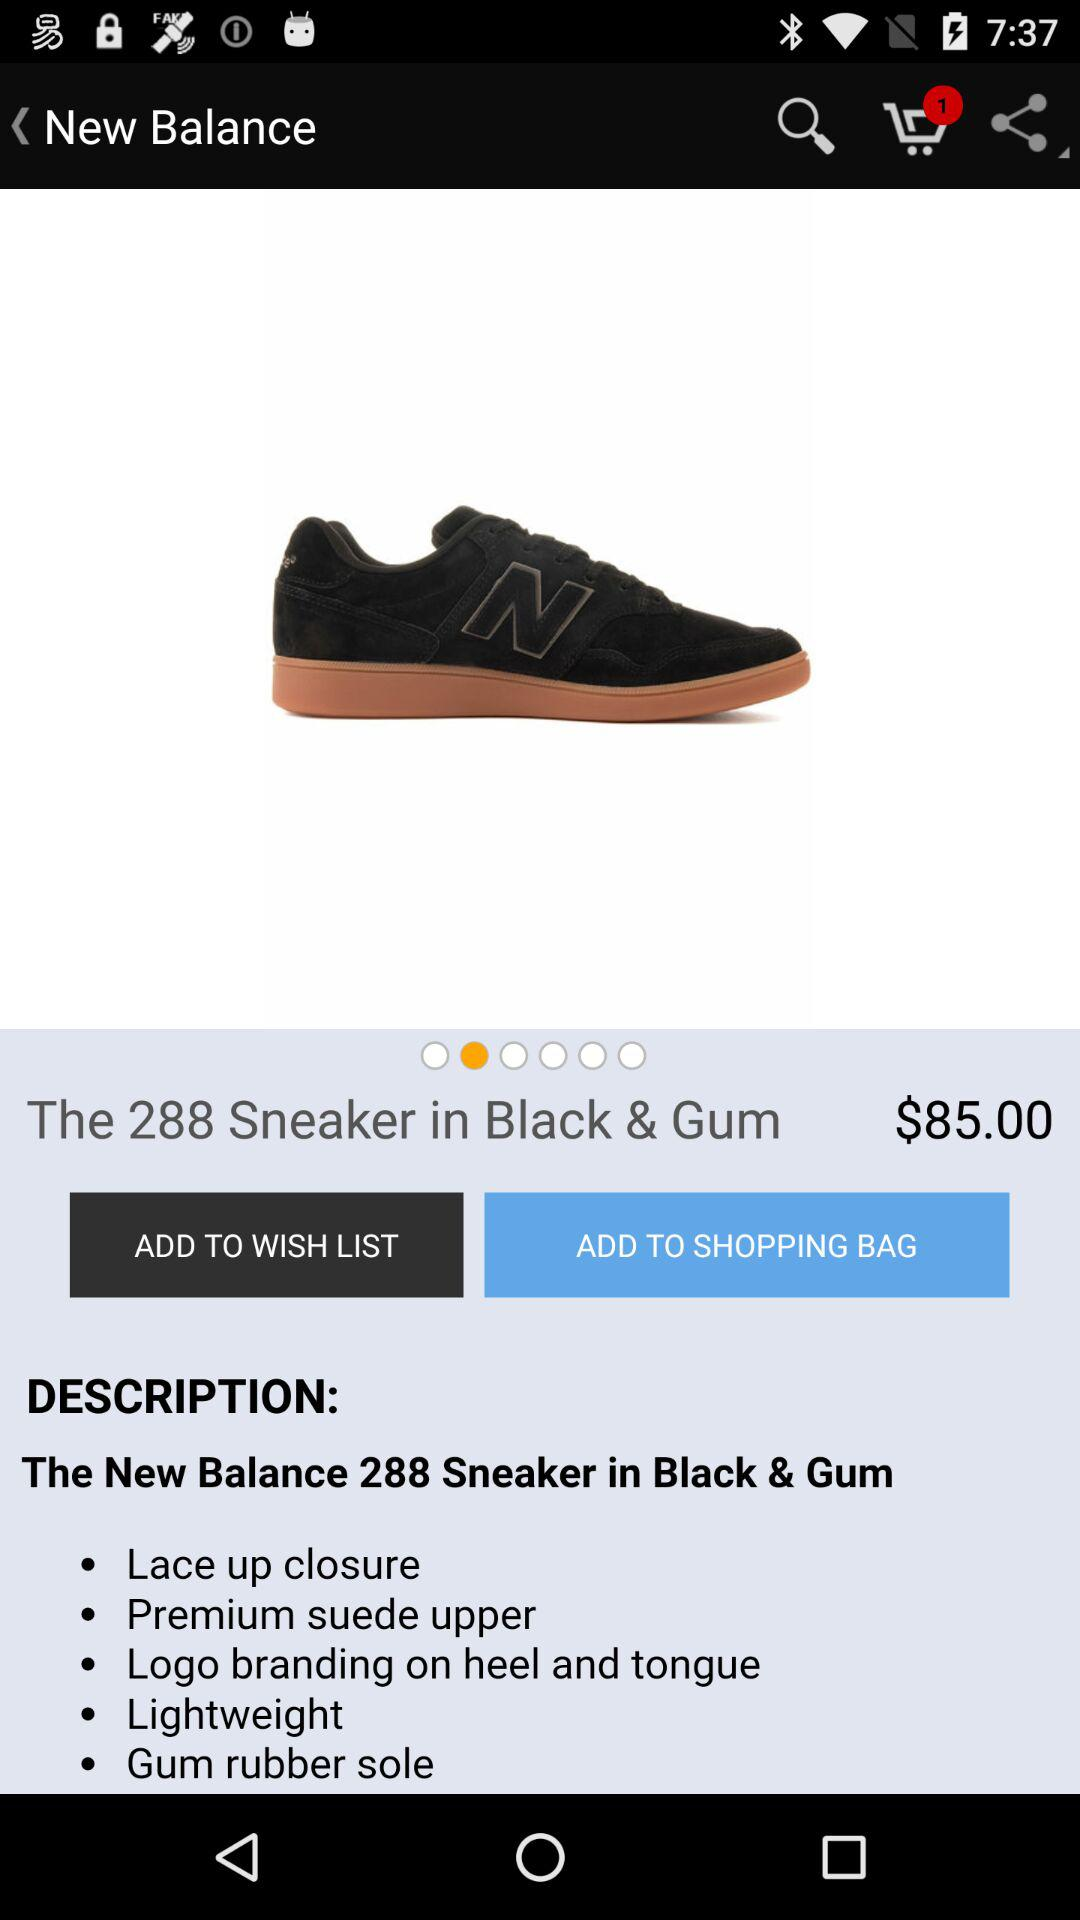What is the color of the shoes? The color is black. 